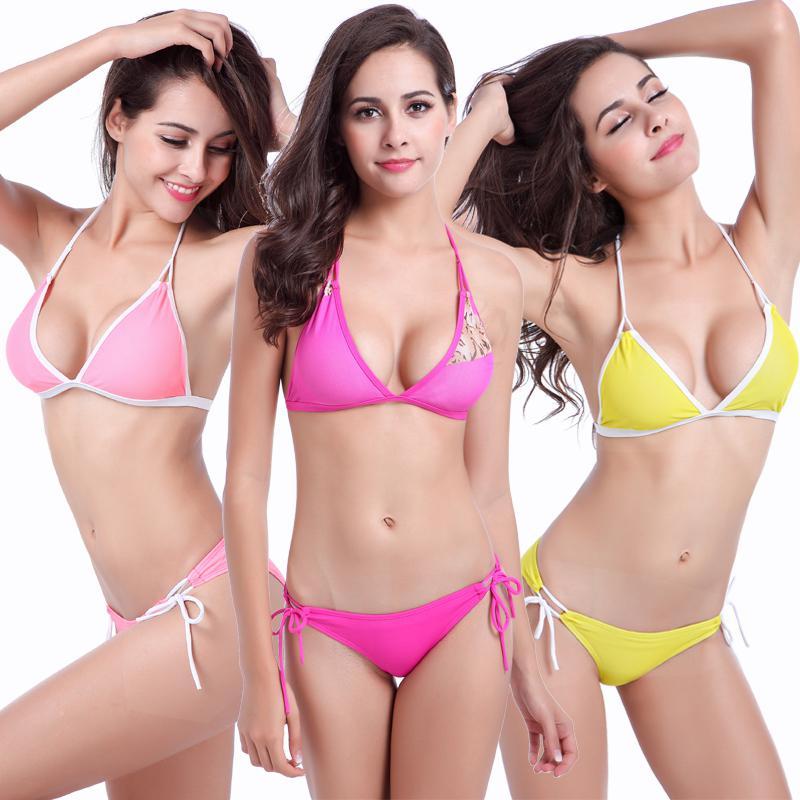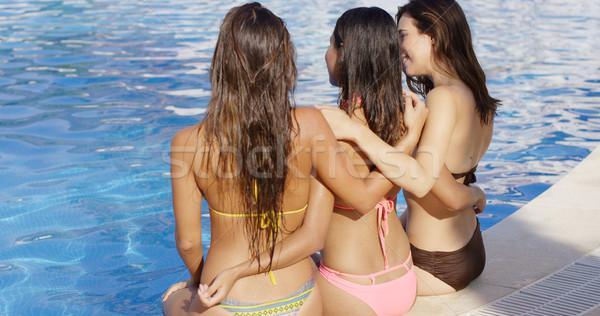The first image is the image on the left, the second image is the image on the right. For the images shown, is this caption "One image shows a trio of bikini models with backs to the camera and arms around each other." true? Answer yes or no. Yes. The first image is the image on the left, the second image is the image on the right. For the images shown, is this caption "One woman poses in a bikini in one image, while three women pose in the other image." true? Answer yes or no. No. 